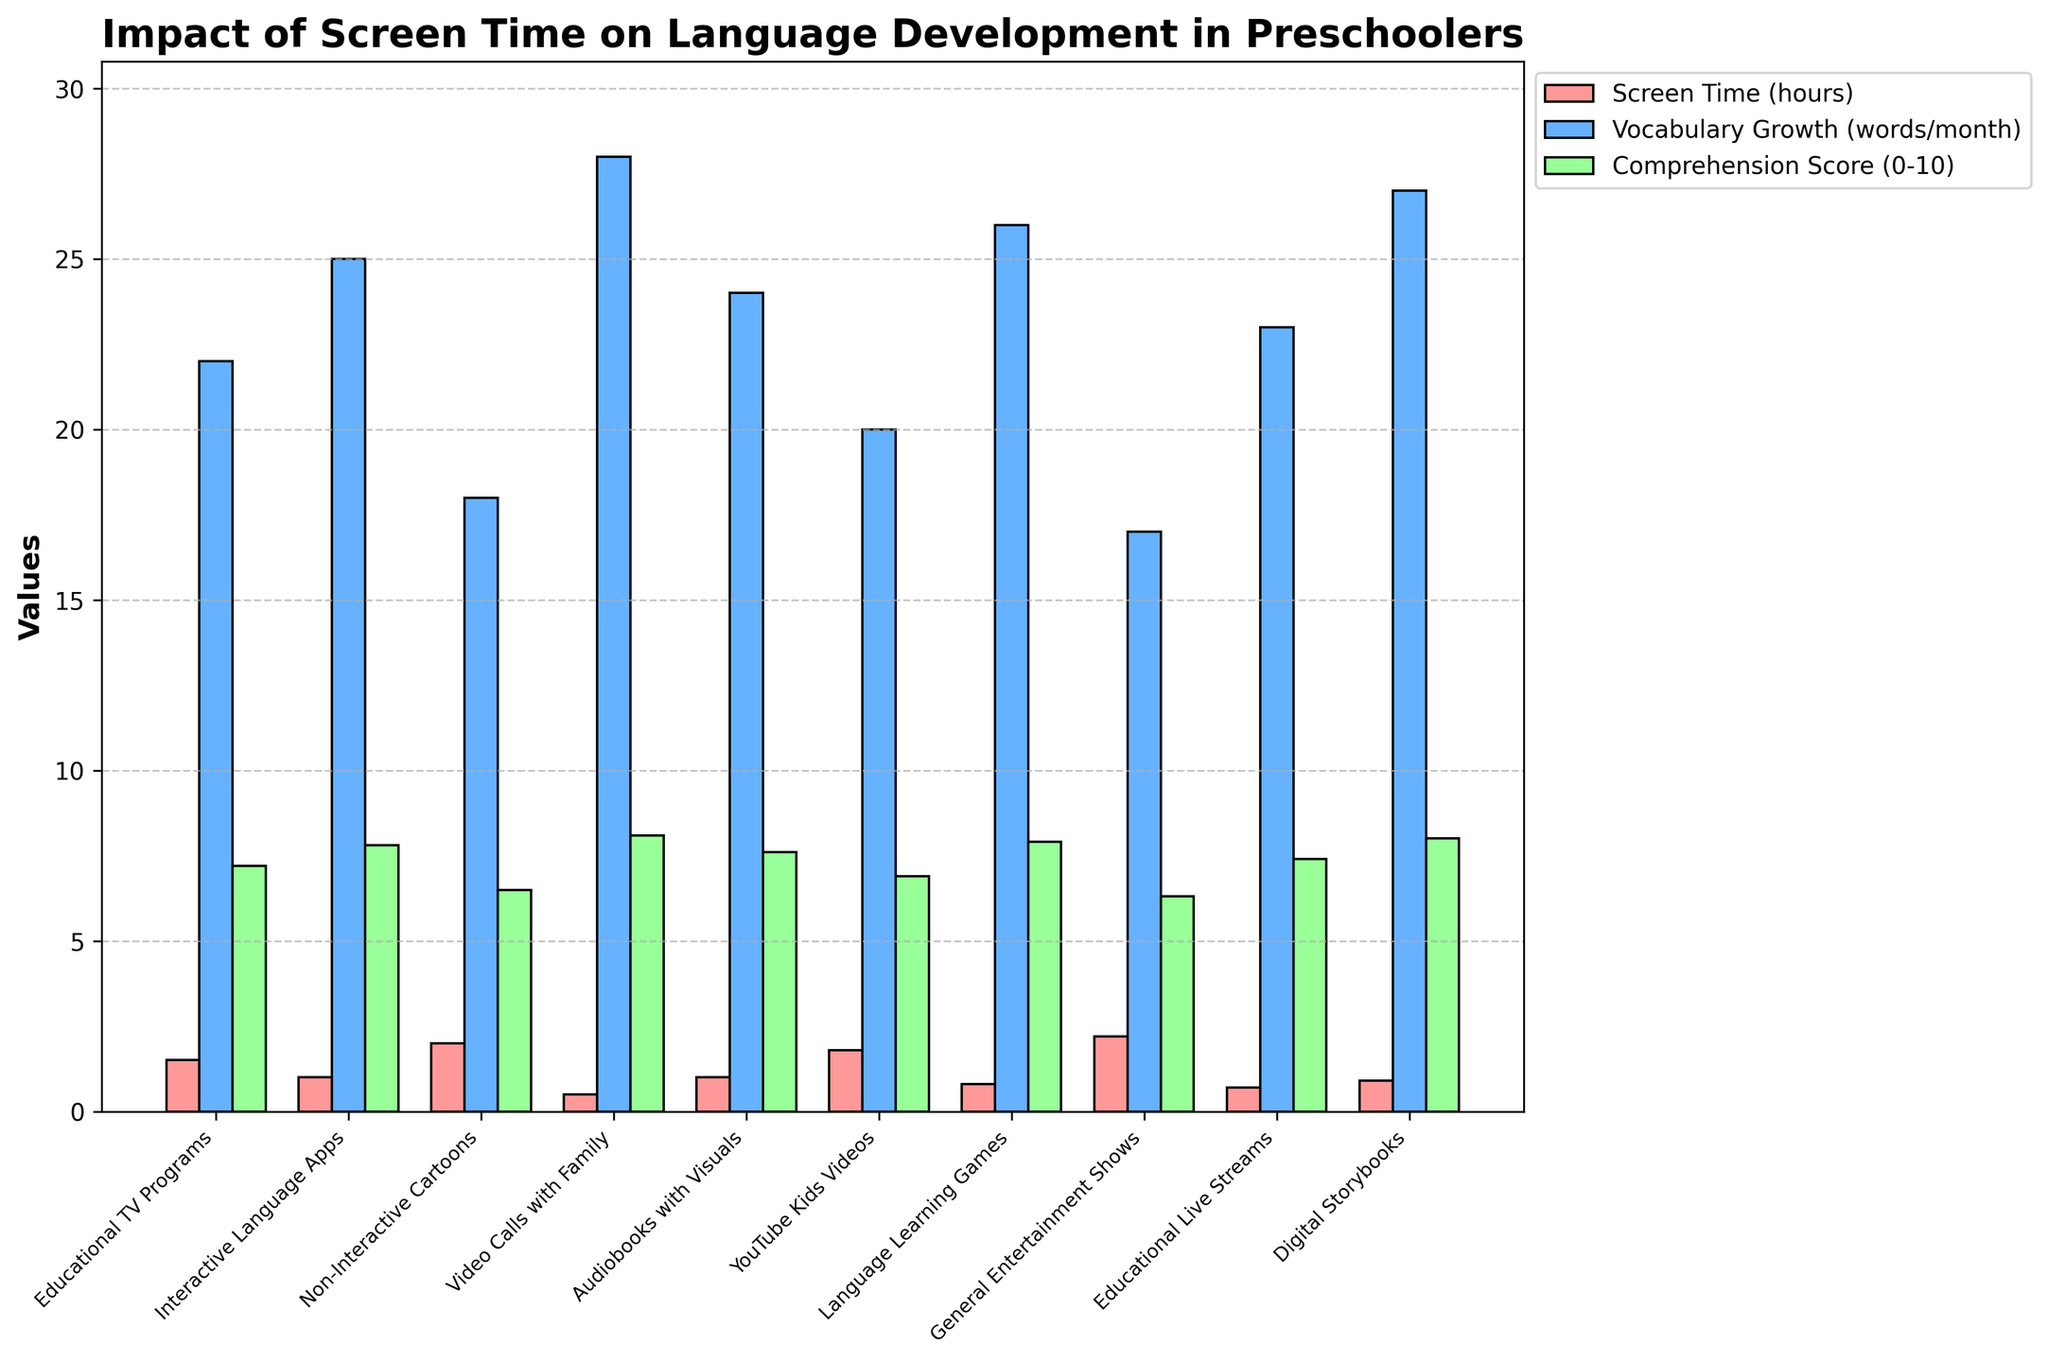Which media type has the highest average daily screen time? Arrange all media types by their average daily screen time and identify the highest one based on the figure. The one with the tallest red bar corresponds to the highest screen time.
Answer: General Entertainment Shows Which media type has the greatest narrative comprehension score? Observe the height of the green bars for each media type. The tallest green bar corresponds to the highest narrative comprehension score.
Answer: Video Calls with Family What is the difference in vocabulary growth between Interactive Language Apps and Non-Interactive Cartoons? Compare the heights of the blue bars for Interactive Language Apps and Non-Interactive Cartoons. Subtract the vocabulary growth of Non-Interactive Cartoons from that of Interactive Language Apps: 25 - 18.
Answer: 7 Which two media types provide the closest narrative comprehension scores? Compare the green bars visually to identify the two that are most similar in height. Digital Storybooks and Language Learning Games both have very close scores: 8.0 and 7.9.
Answer: Digital Storybooks and Language Learning Games What is the total average daily screen time for Educational TV Programs and YouTube Kids Videos? Add the screen times for Educational TV Programs (1.5 hours) and YouTube Kids Videos (1.8 hours). 1.5 + 1.8.
Answer: 3.3 hours How many media types have an average daily screen time of 1 hour or less? Identify the red bars indicating screen times of 1 hour or less. Count these bars. There are Interactive Language Apps, Video Calls with Family, Audiobooks with Visuals, Language Learning Games, Educational Live Streams, and Digital Storybooks.
Answer: 6 Which media type has the lowest vocabulary growth rate? Observe the height of the blue bars and identify the shortest one which represents the lowest vocabulary growth rate.
Answer: General Entertainment Shows What is the sum of narrative comprehension scores for all media types? Add the narrative comprehension scores of all media types: 7.2 + 7.8 + 6.5 + 8.1 + 7.6 + 6.9 + 7.9 + 6.3 + 7.4 + 8.0.
Answer: 73.7 Compare the narrative comprehension scores for YouTube Kids Videos and Non-Interactive Cartoons. Which is higher and by how much? Observe the green bars for YouTube Kids Videos and Non-Interactive Cartoons. Subtract the smaller score from the larger one: 6.9 - 6.5.
Answer: YouTube Kids Videos, by 0.4 